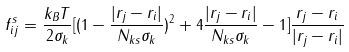Convert formula to latex. <formula><loc_0><loc_0><loc_500><loc_500>f ^ { s } _ { i j } = \frac { k _ { B } T } { 2 \sigma _ { k } } [ ( 1 - \frac { | r _ { j } - r _ { i } | } { N _ { k s } \sigma _ { k } } ) ^ { 2 } + 4 \frac { | r _ { j } - r _ { i } | } { N _ { k s } \sigma _ { k } } - 1 ] \frac { r _ { j } - r _ { i } } { | r _ { j } - r _ { i } | }</formula> 